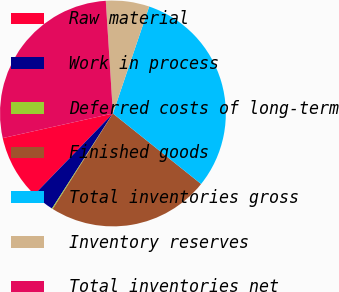<chart> <loc_0><loc_0><loc_500><loc_500><pie_chart><fcel>Raw material<fcel>Work in process<fcel>Deferred costs of long-term<fcel>Finished goods<fcel>Total inventories gross<fcel>Inventory reserves<fcel>Total inventories net<nl><fcel>9.25%<fcel>3.17%<fcel>0.13%<fcel>23.21%<fcel>30.53%<fcel>6.21%<fcel>27.49%<nl></chart> 